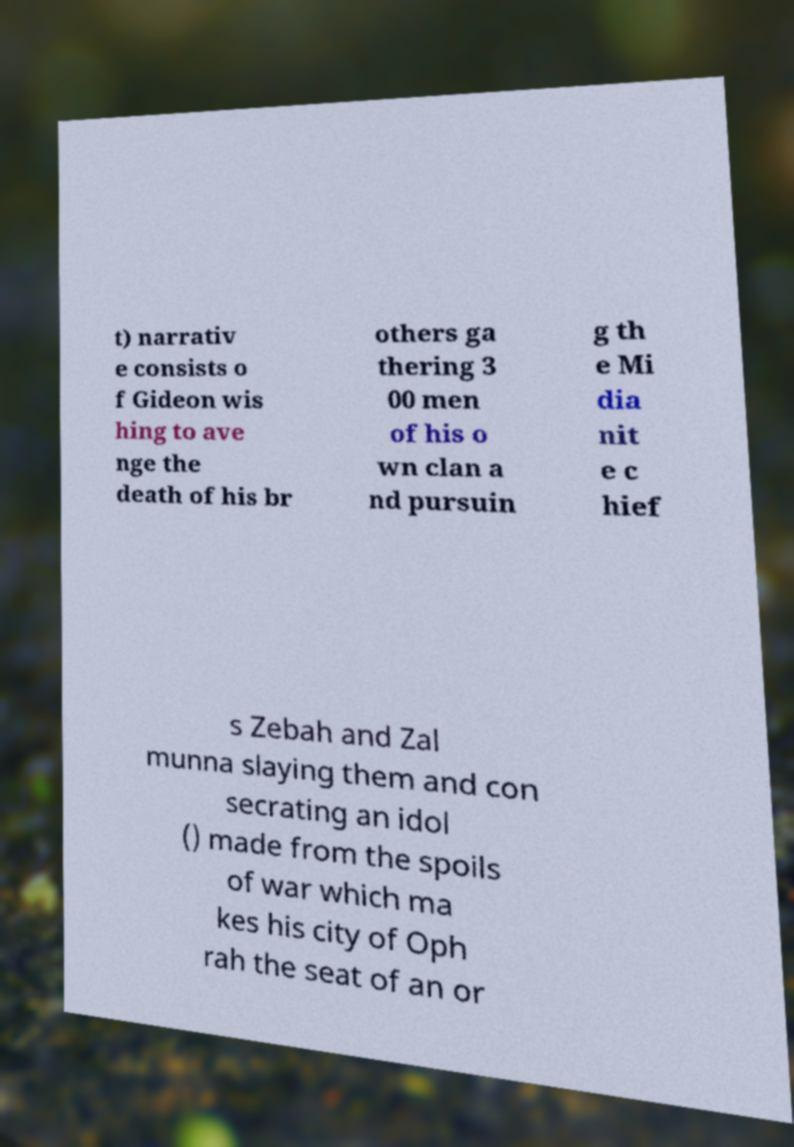Can you accurately transcribe the text from the provided image for me? t) narrativ e consists o f Gideon wis hing to ave nge the death of his br others ga thering 3 00 men of his o wn clan a nd pursuin g th e Mi dia nit e c hief s Zebah and Zal munna slaying them and con secrating an idol () made from the spoils of war which ma kes his city of Oph rah the seat of an or 